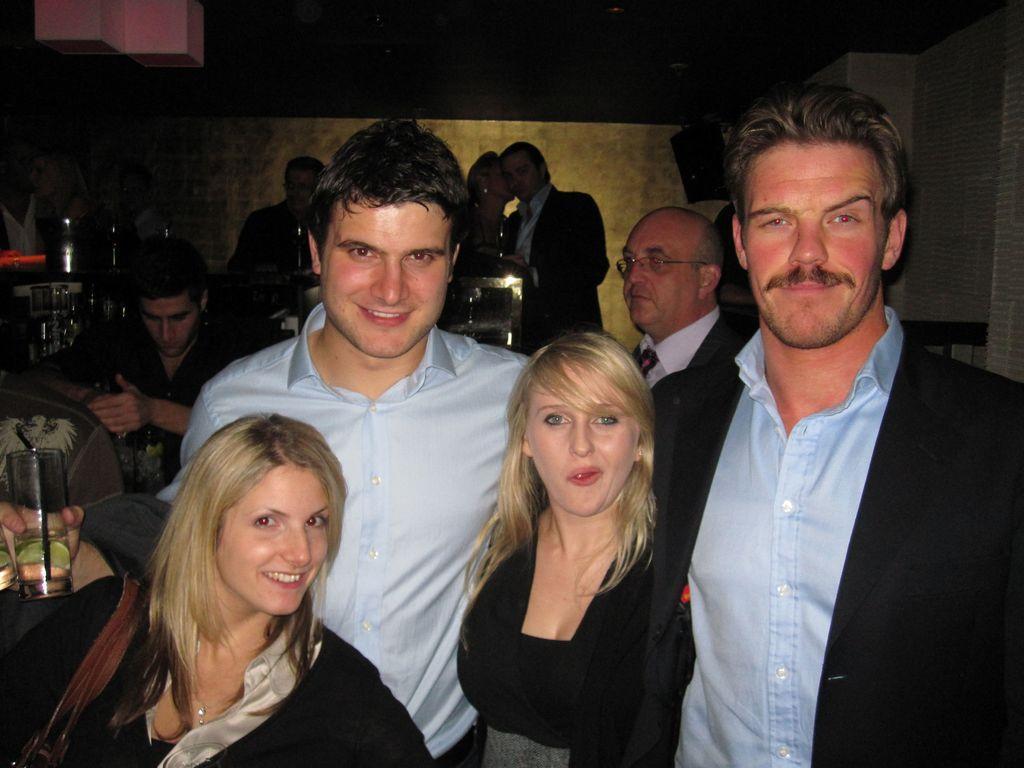Describe this image in one or two sentences. In this image there are people sitting on chairs and few are standing. 